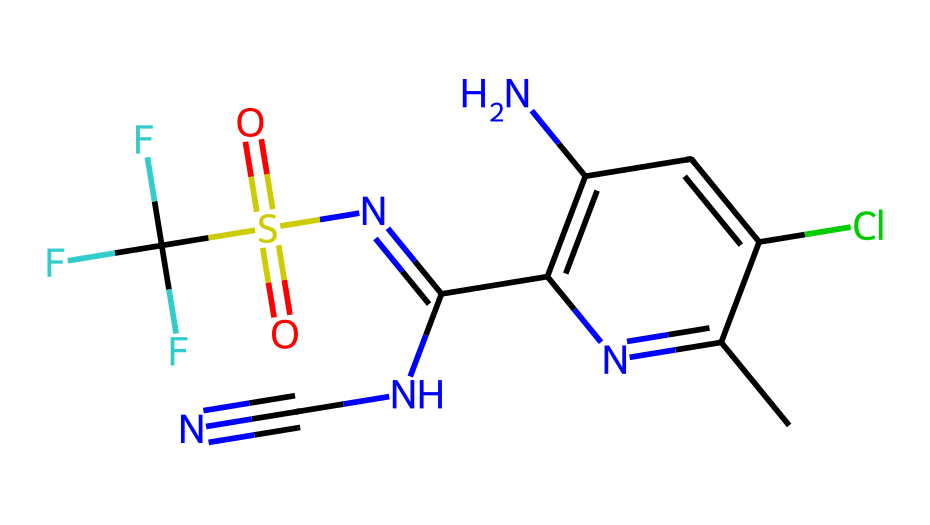What is the primary function of fipronil? Fipronil is primarily used to disrupt the nervous system of insects, which leads to their death. The chemical structure of fipronil targets specific receptors in the insect's brain, affecting its ability to send signals.
Answer: insecticide How many nitrogen atoms are present in the chemical structure of fipronil? By analyzing the structure, we can count the distinct nitrogen atoms. In the SMILES representation, we identify four occurrences of nitrogen indicated by 'N', which confirms their presence.
Answer: 4 What type of bond characterizes the relationship between the nitrogen atoms in fipronil? The bonding between the nitrogen atoms is primarily characterized by covalent bonds. This involves the sharing of electron pairs between the N atoms, as seen in the structure and typical behavior of organic compounds.
Answer: covalent Is there a functional group in fipronil that suggests it is a sulfonamide? Yes, the presence of the sulfonyl group (S(=O)(=O)) in the structure indicates that fipronil has sulfonamide characteristics, distinguishing it from other chemical classes.
Answer: yes What is the significance of the trifluoromethyl group in fipronil's effectiveness? The trifluoromethyl group is highly electronegative and contributes to the chemical's lipophilicity and stability, enhancing its efficacy as an insecticide. Its unique electronegative properties allow for greater interaction with target receptors.
Answer: enhances efficacy 